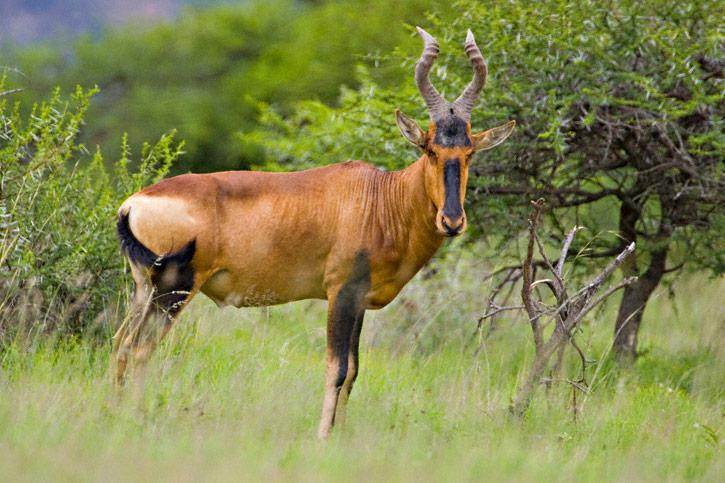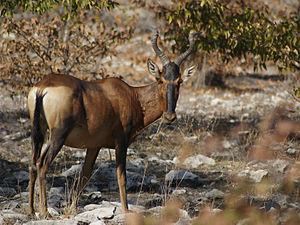The first image is the image on the left, the second image is the image on the right. Analyze the images presented: Is the assertion "An image shows exactly five hooved animals with horns." valid? Answer yes or no. No. The first image is the image on the left, the second image is the image on the right. Assess this claim about the two images: "there is exactly one animal in the image on the left". Correct or not? Answer yes or no. Yes. 